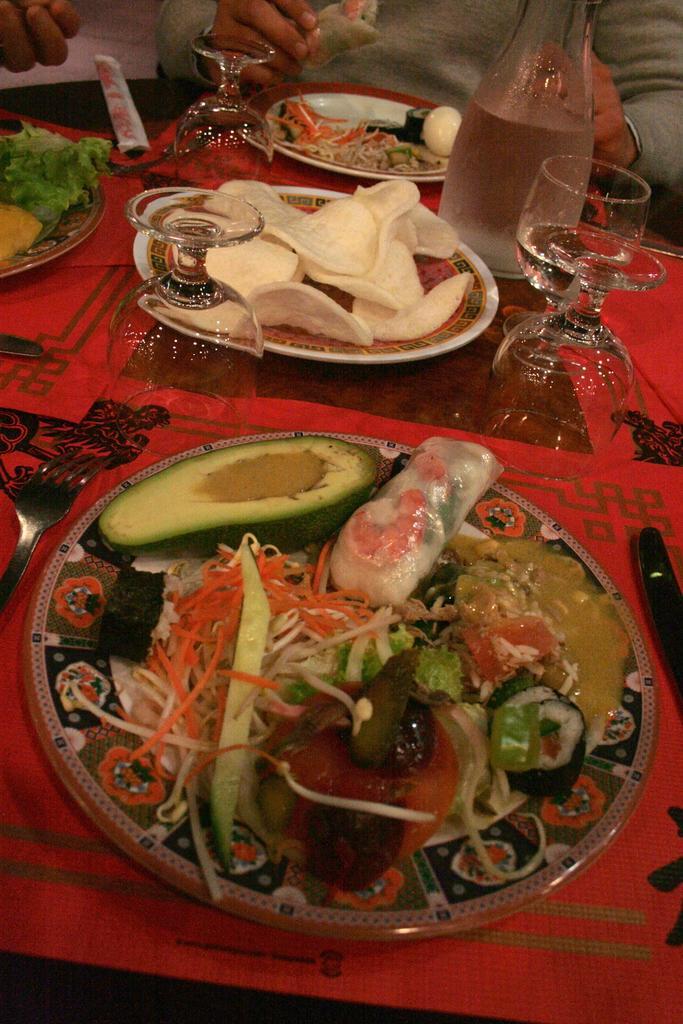Please provide a concise description of this image. At the bottom of the image there is a table, on the table there are some plates, glasses and bowls and food and spoon and fork and knife. Behind the table a person is sitting. 